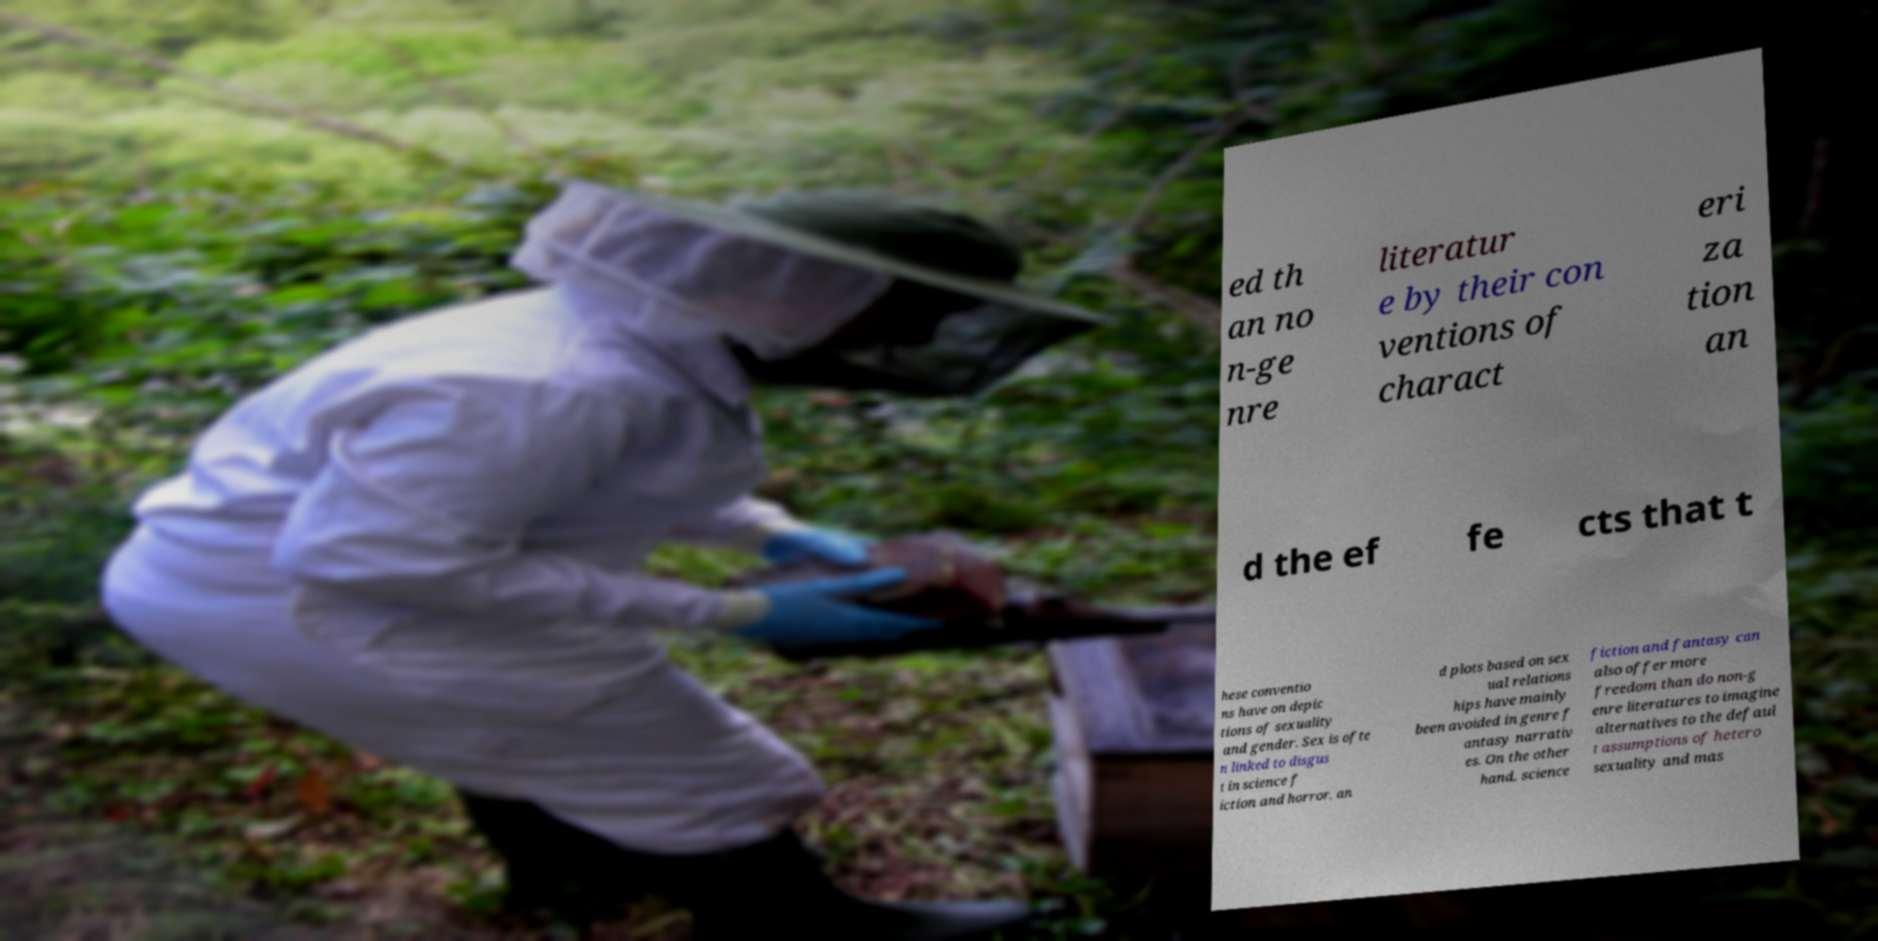There's text embedded in this image that I need extracted. Can you transcribe it verbatim? ed th an no n-ge nre literatur e by their con ventions of charact eri za tion an d the ef fe cts that t hese conventio ns have on depic tions of sexuality and gender. Sex is ofte n linked to disgus t in science f iction and horror, an d plots based on sex ual relations hips have mainly been avoided in genre f antasy narrativ es. On the other hand, science fiction and fantasy can also offer more freedom than do non-g enre literatures to imagine alternatives to the defaul t assumptions of hetero sexuality and mas 